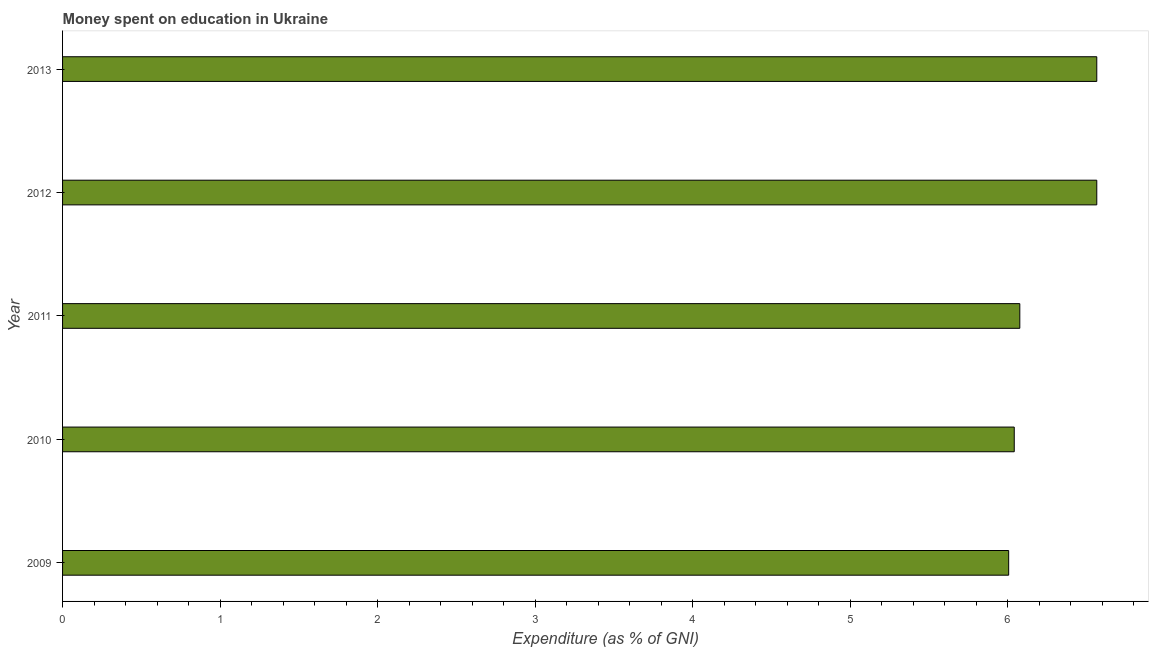Does the graph contain grids?
Offer a very short reply. No. What is the title of the graph?
Keep it short and to the point. Money spent on education in Ukraine. What is the label or title of the X-axis?
Keep it short and to the point. Expenditure (as % of GNI). What is the expenditure on education in 2011?
Provide a short and direct response. 6.08. Across all years, what is the maximum expenditure on education?
Your response must be concise. 6.57. Across all years, what is the minimum expenditure on education?
Keep it short and to the point. 6.01. What is the sum of the expenditure on education?
Give a very brief answer. 31.25. What is the average expenditure on education per year?
Your answer should be compact. 6.25. What is the median expenditure on education?
Provide a short and direct response. 6.08. In how many years, is the expenditure on education greater than 6.2 %?
Provide a succinct answer. 2. What is the ratio of the expenditure on education in 2009 to that in 2012?
Provide a short and direct response. 0.92. Is the expenditure on education in 2009 less than that in 2013?
Make the answer very short. Yes. Is the sum of the expenditure on education in 2010 and 2011 greater than the maximum expenditure on education across all years?
Provide a short and direct response. Yes. What is the difference between the highest and the lowest expenditure on education?
Provide a short and direct response. 0.56. In how many years, is the expenditure on education greater than the average expenditure on education taken over all years?
Offer a terse response. 2. How many bars are there?
Provide a succinct answer. 5. Are the values on the major ticks of X-axis written in scientific E-notation?
Offer a terse response. No. What is the Expenditure (as % of GNI) of 2009?
Your answer should be compact. 6.01. What is the Expenditure (as % of GNI) of 2010?
Ensure brevity in your answer.  6.04. What is the Expenditure (as % of GNI) of 2011?
Offer a very short reply. 6.08. What is the Expenditure (as % of GNI) of 2012?
Your response must be concise. 6.57. What is the Expenditure (as % of GNI) of 2013?
Give a very brief answer. 6.57. What is the difference between the Expenditure (as % of GNI) in 2009 and 2010?
Offer a very short reply. -0.04. What is the difference between the Expenditure (as % of GNI) in 2009 and 2011?
Keep it short and to the point. -0.07. What is the difference between the Expenditure (as % of GNI) in 2009 and 2012?
Your response must be concise. -0.56. What is the difference between the Expenditure (as % of GNI) in 2009 and 2013?
Your response must be concise. -0.56. What is the difference between the Expenditure (as % of GNI) in 2010 and 2011?
Ensure brevity in your answer.  -0.04. What is the difference between the Expenditure (as % of GNI) in 2010 and 2012?
Offer a terse response. -0.52. What is the difference between the Expenditure (as % of GNI) in 2010 and 2013?
Keep it short and to the point. -0.52. What is the difference between the Expenditure (as % of GNI) in 2011 and 2012?
Keep it short and to the point. -0.49. What is the difference between the Expenditure (as % of GNI) in 2011 and 2013?
Ensure brevity in your answer.  -0.49. What is the difference between the Expenditure (as % of GNI) in 2012 and 2013?
Your answer should be compact. 0. What is the ratio of the Expenditure (as % of GNI) in 2009 to that in 2010?
Your answer should be very brief. 0.99. What is the ratio of the Expenditure (as % of GNI) in 2009 to that in 2011?
Keep it short and to the point. 0.99. What is the ratio of the Expenditure (as % of GNI) in 2009 to that in 2012?
Make the answer very short. 0.92. What is the ratio of the Expenditure (as % of GNI) in 2009 to that in 2013?
Your response must be concise. 0.92. What is the ratio of the Expenditure (as % of GNI) in 2010 to that in 2011?
Give a very brief answer. 0.99. What is the ratio of the Expenditure (as % of GNI) in 2010 to that in 2012?
Provide a succinct answer. 0.92. What is the ratio of the Expenditure (as % of GNI) in 2010 to that in 2013?
Your answer should be very brief. 0.92. What is the ratio of the Expenditure (as % of GNI) in 2011 to that in 2012?
Your answer should be very brief. 0.93. What is the ratio of the Expenditure (as % of GNI) in 2011 to that in 2013?
Provide a succinct answer. 0.93. 